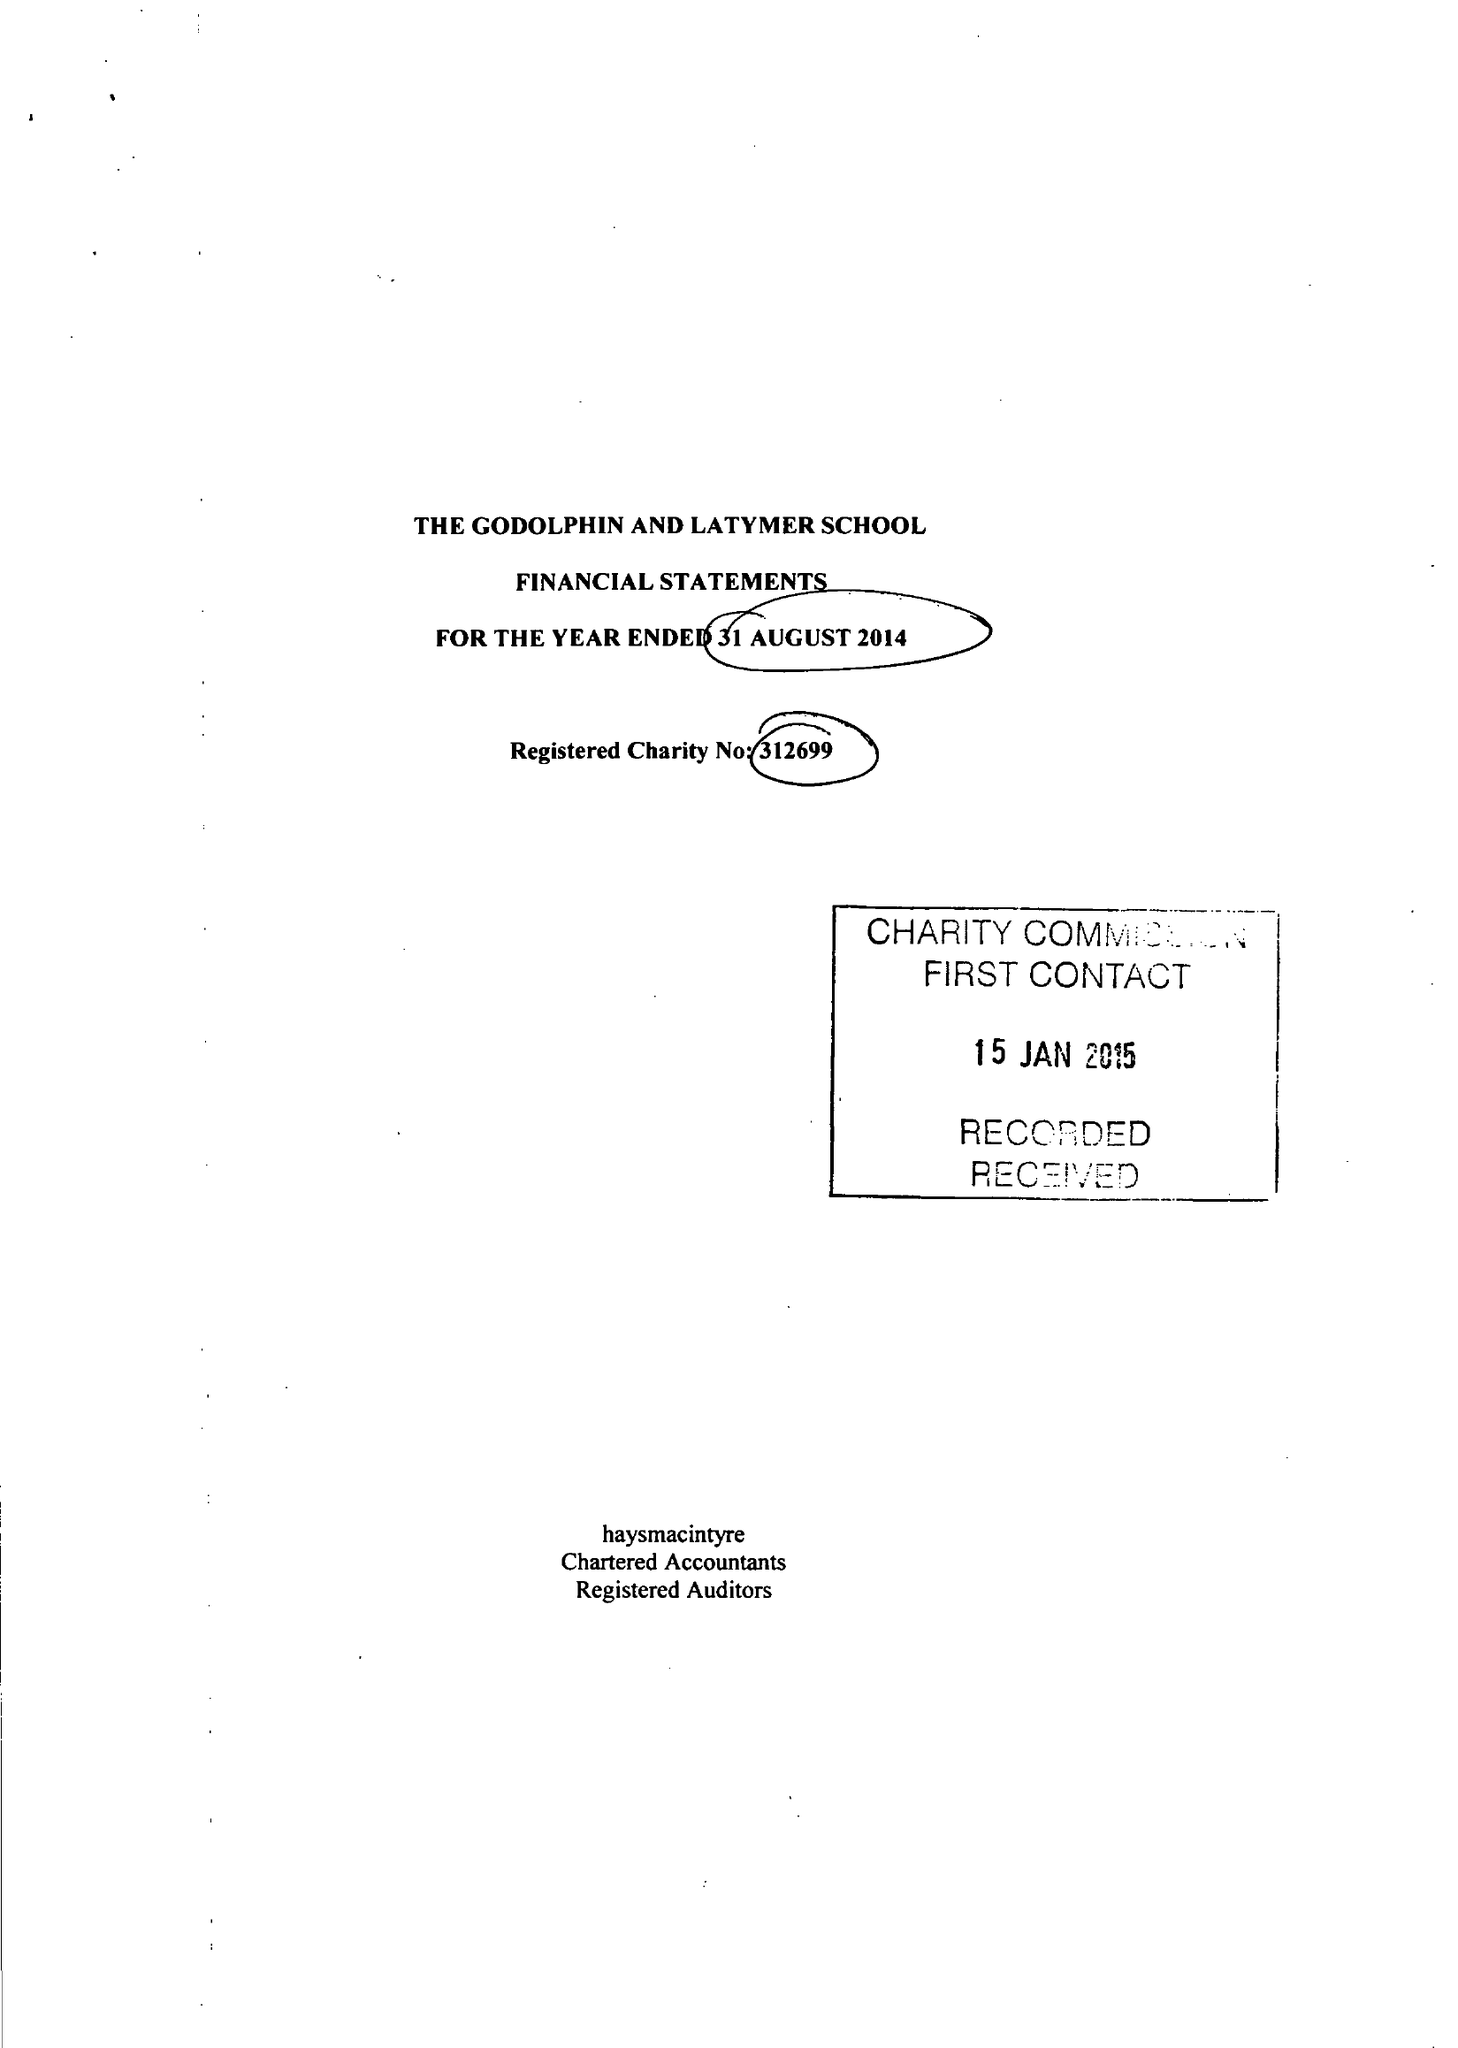What is the value for the address__street_line?
Answer the question using a single word or phrase. IFFLEY ROAD 